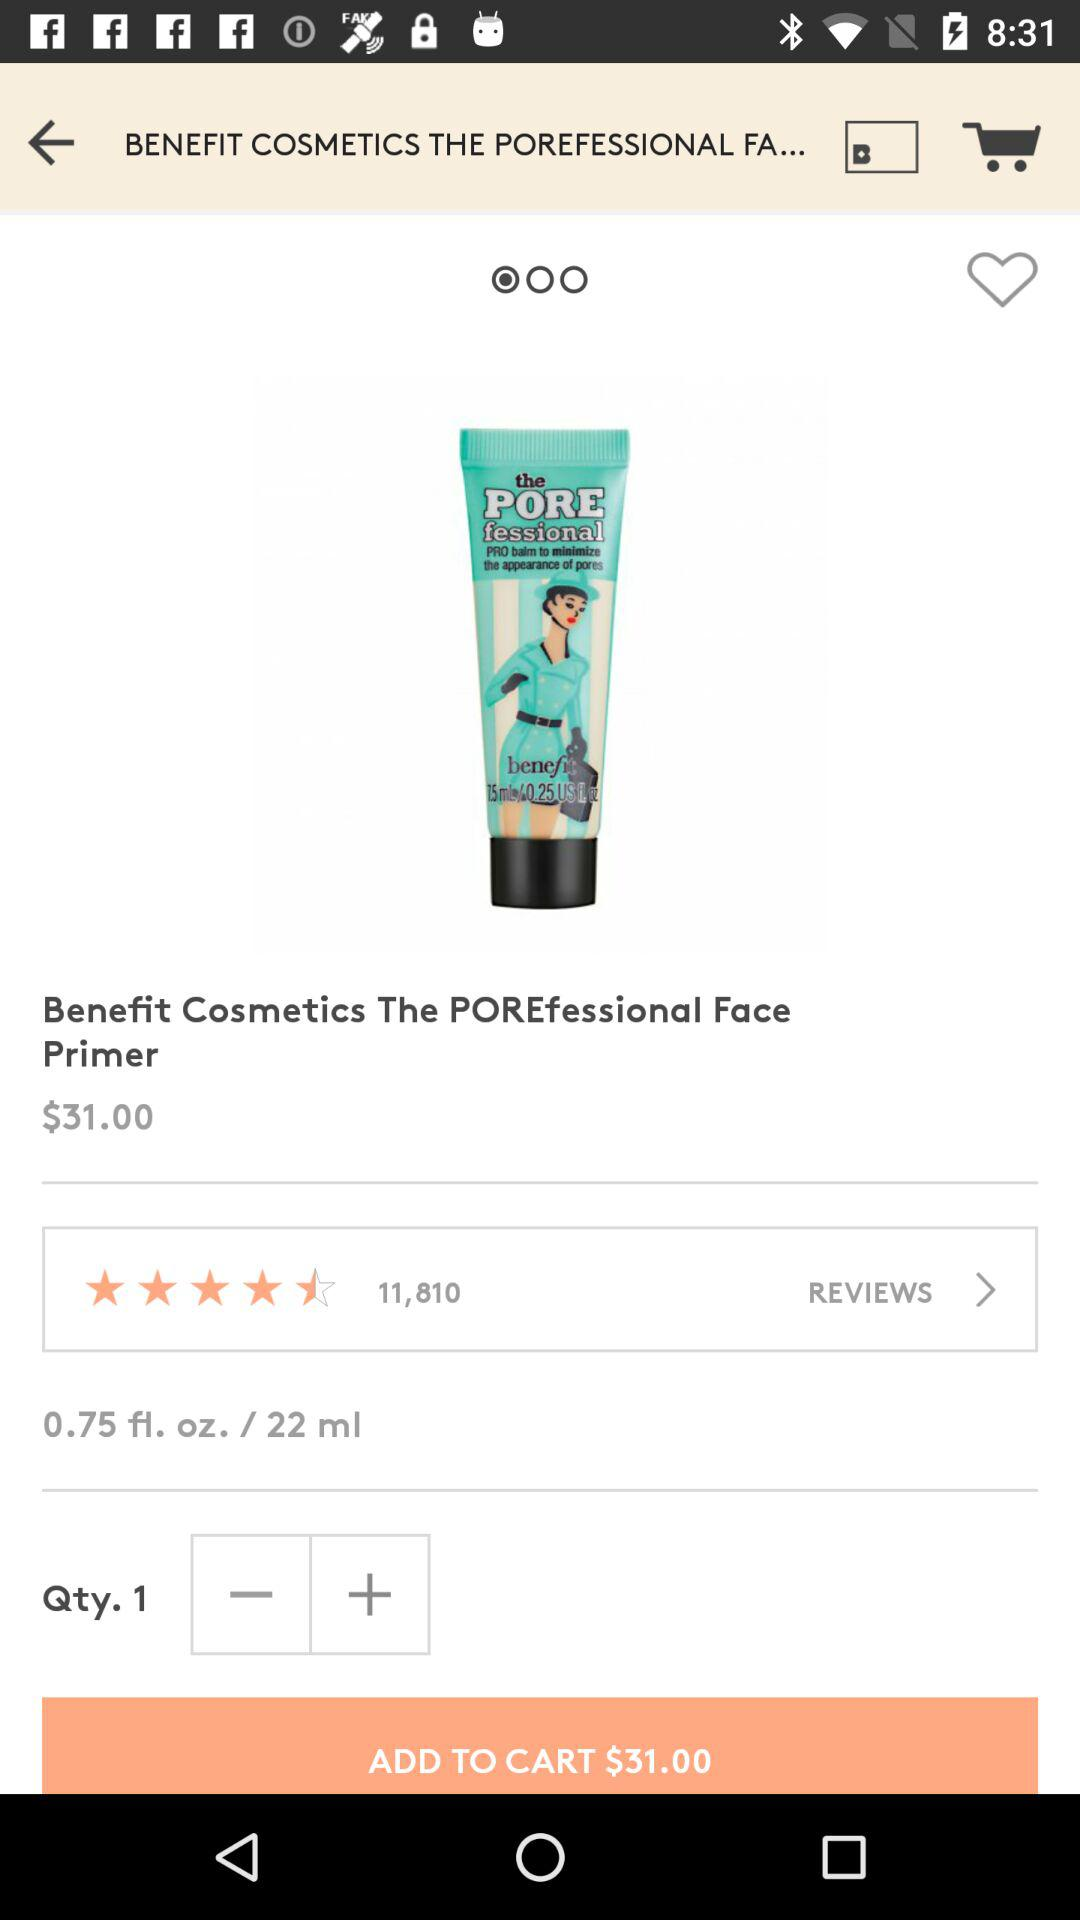What is the name of the product? The name of the product is "Benefit Cosmetics The POREfessional Face Primer". 